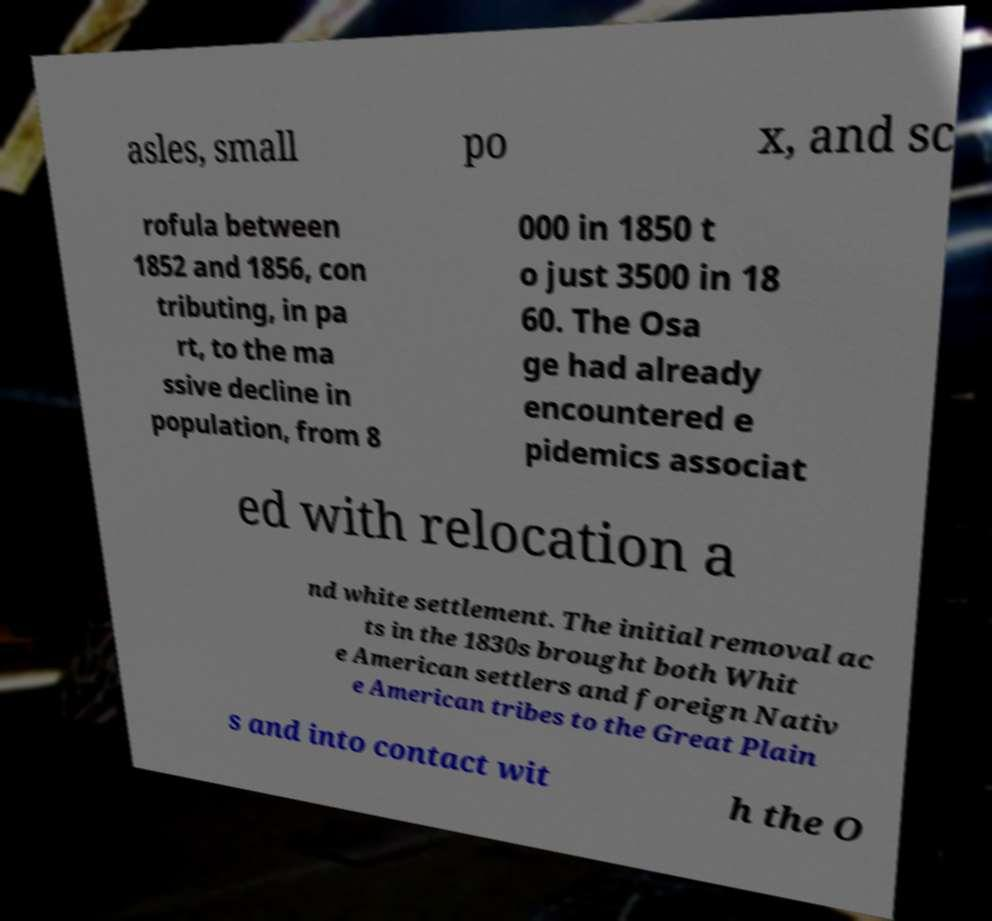For documentation purposes, I need the text within this image transcribed. Could you provide that? asles, small po x, and sc rofula between 1852 and 1856, con tributing, in pa rt, to the ma ssive decline in population, from 8 000 in 1850 t o just 3500 in 18 60. The Osa ge had already encountered e pidemics associat ed with relocation a nd white settlement. The initial removal ac ts in the 1830s brought both Whit e American settlers and foreign Nativ e American tribes to the Great Plain s and into contact wit h the O 